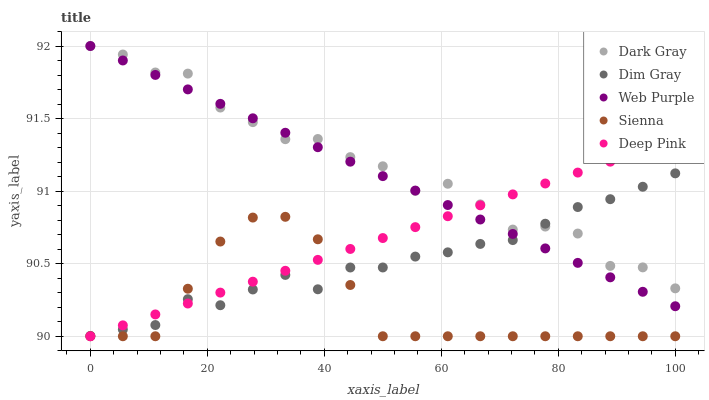Does Sienna have the minimum area under the curve?
Answer yes or no. Yes. Does Dark Gray have the maximum area under the curve?
Answer yes or no. Yes. Does Web Purple have the minimum area under the curve?
Answer yes or no. No. Does Web Purple have the maximum area under the curve?
Answer yes or no. No. Is Web Purple the smoothest?
Answer yes or no. Yes. Is Dark Gray the roughest?
Answer yes or no. Yes. Is Sienna the smoothest?
Answer yes or no. No. Is Sienna the roughest?
Answer yes or no. No. Does Sienna have the lowest value?
Answer yes or no. Yes. Does Web Purple have the lowest value?
Answer yes or no. No. Does Web Purple have the highest value?
Answer yes or no. Yes. Does Sienna have the highest value?
Answer yes or no. No. Is Sienna less than Dark Gray?
Answer yes or no. Yes. Is Web Purple greater than Sienna?
Answer yes or no. Yes. Does Deep Pink intersect Dark Gray?
Answer yes or no. Yes. Is Deep Pink less than Dark Gray?
Answer yes or no. No. Is Deep Pink greater than Dark Gray?
Answer yes or no. No. Does Sienna intersect Dark Gray?
Answer yes or no. No. 